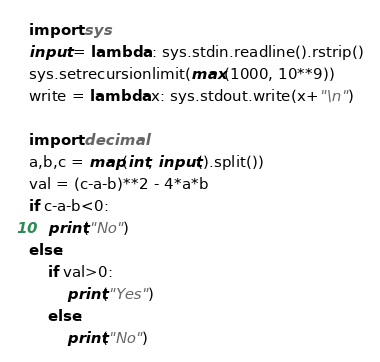<code> <loc_0><loc_0><loc_500><loc_500><_Python_>import sys
input = lambda : sys.stdin.readline().rstrip()
sys.setrecursionlimit(max(1000, 10**9))
write = lambda x: sys.stdout.write(x+"\n")

import decimal
a,b,c = map(int, input().split())
val = (c-a-b)**2 - 4*a*b
if c-a-b<0:
    print("No")
else:
    if val>0:
        print("Yes")
    else:
        print("No")</code> 